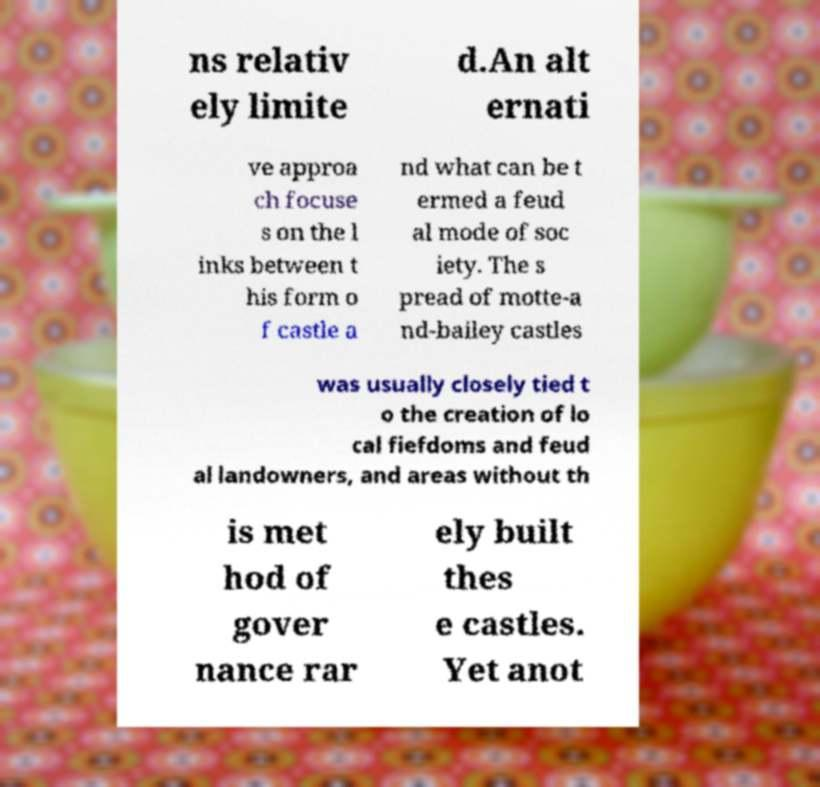For documentation purposes, I need the text within this image transcribed. Could you provide that? ns relativ ely limite d.An alt ernati ve approa ch focuse s on the l inks between t his form o f castle a nd what can be t ermed a feud al mode of soc iety. The s pread of motte-a nd-bailey castles was usually closely tied t o the creation of lo cal fiefdoms and feud al landowners, and areas without th is met hod of gover nance rar ely built thes e castles. Yet anot 